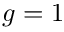<formula> <loc_0><loc_0><loc_500><loc_500>g = 1</formula> 